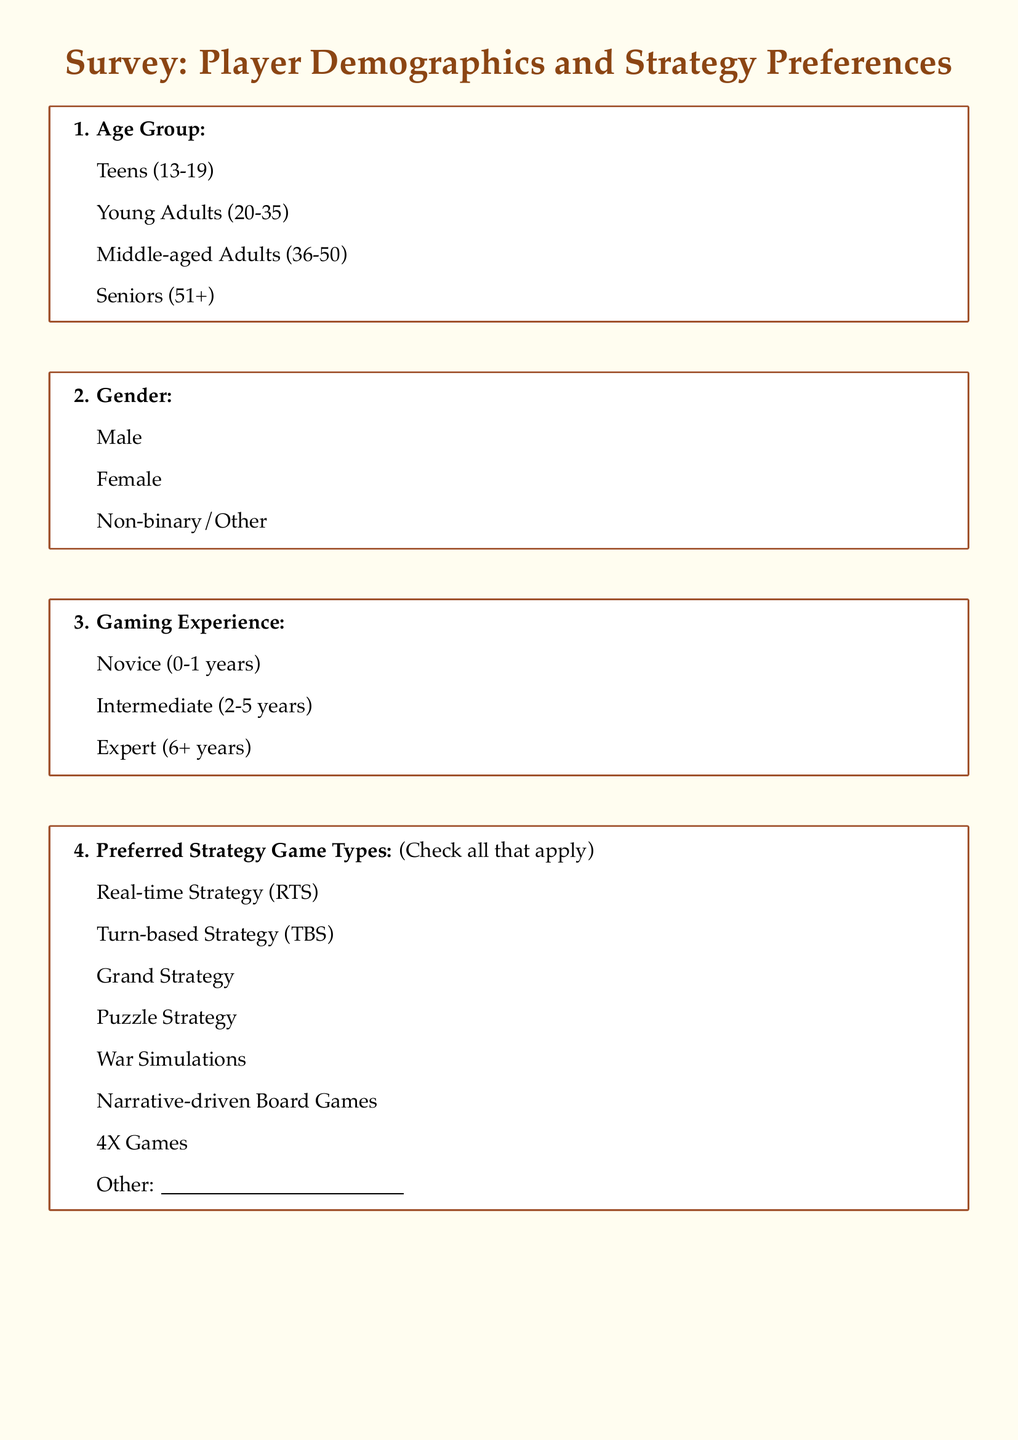What are the age groups listed in the survey? The document specifies four different age groups for respondents to choose from.
Answer: Teens, Young Adults, Middle-aged Adults, Seniors How many years of gaming experience does an Intermediate player have? The document categorizes gaming experience into three types, explicitly listing the years associated with the Intermediate category.
Answer: 2-5 years What is the highest rank you can give to the aspects of strategy games? The ranking system outlined in the survey allows respondents to assign ranks from 1 to 5, where 1 is the highest.
Answer: 5 What aspect of strategy games is labeled as "most important" in the survey? The question allows respondents to rank various aspects of strategy games in order of importance, indicating preferences for those aspects.
Answer: Complex mechanics How many strategy game types can be selected by respondents? The survey allows checking multiple options under the preferred strategy game types, giving insight into the variety permitted.
Answer: Multiple (not a specific number) Is the storyline considered very important by some respondents? The survey asks about the importance of the storyline and offers the option indicating that it can be considered very important by respondents.
Answer: Yes 